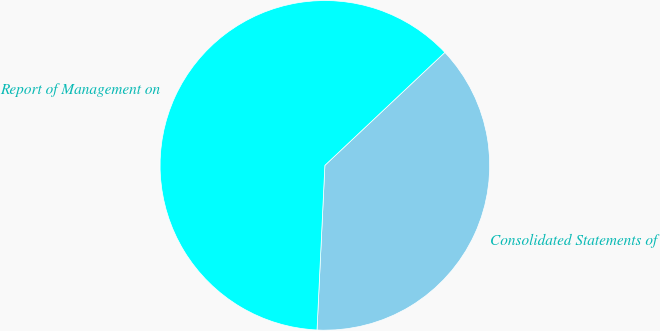Convert chart. <chart><loc_0><loc_0><loc_500><loc_500><pie_chart><fcel>Consolidated Statements of<fcel>Report of Management on<nl><fcel>37.78%<fcel>62.22%<nl></chart> 